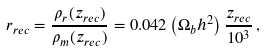Convert formula to latex. <formula><loc_0><loc_0><loc_500><loc_500>r _ { r e c } = \frac { \rho _ { r } ( z _ { r e c } ) } { \rho _ { m } ( z _ { r e c } ) } = 0 . 0 4 2 \left ( \Omega _ { b } h ^ { 2 } \right ) \frac { z _ { r e c } } { 1 0 ^ { 3 } } \, ,</formula> 